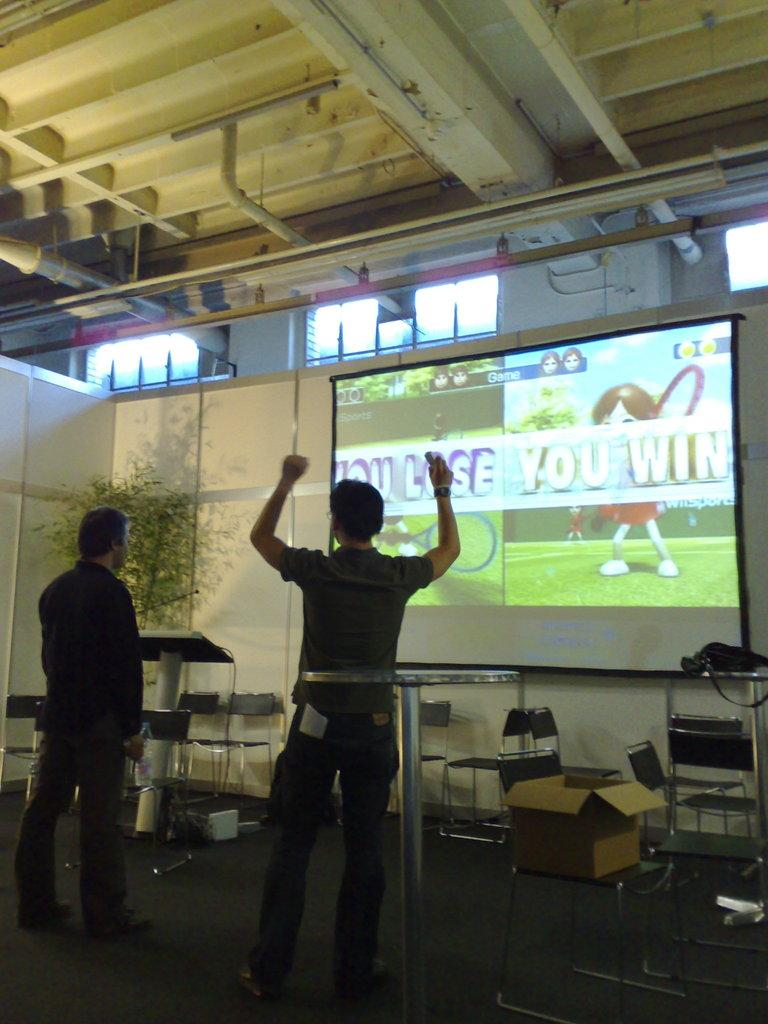<image>
Describe the image concisely. Two men are standing in front of a large, split screen that is announcing one of them as a winner and the other a looser. 